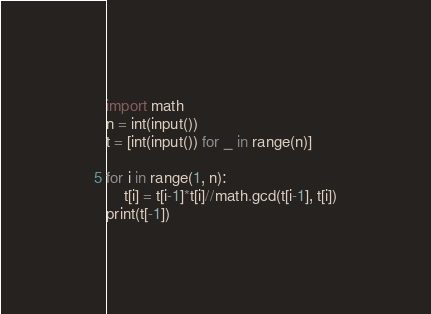<code> <loc_0><loc_0><loc_500><loc_500><_Python_>import math
n = int(input())
t = [int(input()) for _ in range(n)]

for i in range(1, n):
    t[i] = t[i-1]*t[i]//math.gcd(t[i-1], t[i])
print(t[-1])</code> 